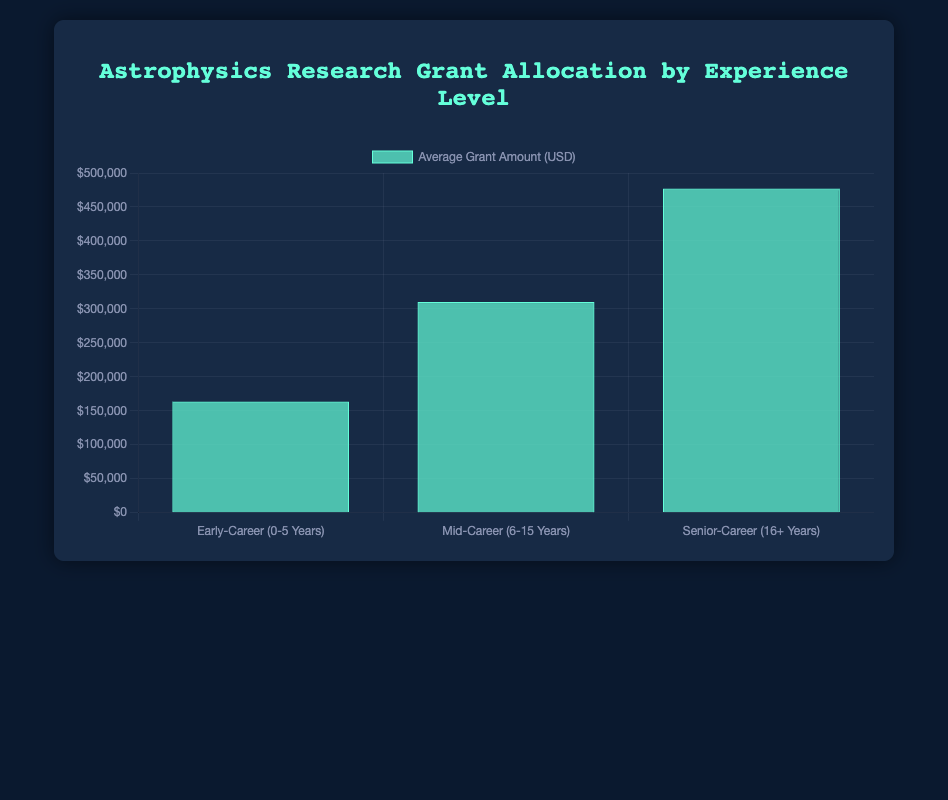What is the average grant amount for Early-Career investigators? To find the average grant amount for Early-Career investigators, sum the grant amounts for Dr. Naomi Williams, Dr. Emily Chen, and Dr. David Lee: 150,000 + 180,000 + 160,000 = 490,000. Then divide by the number of Early-Career investigators, which is 3: 490,000 / 3 = 163,333.33
Answer: 163,333.33 Which experience level received the highest average grant allocation? By looking at the bar chart, observe the height of the bars representing each experience level. The tallest bar corresponds to the Senior-Career level, indicating they received the highest average grant allocation.
Answer: Senior-Career How much more, on average, does a Senior-Career investigator receive compared to an Early-Career investigator? First, identify the average grant for Senior-Career investigators, which is depicted as approximately $476,667. The average for Early-Career is $163,333.33. Subtract the Early-Career average from the Senior-Career average: 476,667 - 163,333.33 = 313,333.67
Answer: 313,333.67 What is the total grant amount awarded to Mid-Career investigators? Sum the grant amounts for Dr. Alan Reyes, Dr. Michael Garcia, and Dr. Rachel Adams: 300,000 + 320,000 + 310,000 = 930,000
Answer: 930,000 Which experience level has the smallest average grant allocation, and what is the amount? By examining the bar chart, the shortest bar represents the Early-Career level, indicating they have the smallest average grant allocation. The amount for Early-Career investigators is approximately $163,333.33
Answer: Early-Career, 163,333.33 Compare the average grant allocations between Early-Career and Mid-Career investigators. From the chart, the average for Early-Career is approximately $163,333.33, and for Mid-Career, it's around $310,000. Mid-Career investigators receive significantly higher average grants compared to Early-Career investigators.
Answer: Mid-Career > Early-Career If the total budget for grants was $2,000,000, how much of the budget remains after allocations? The total grants awarded sum to $490,000 (Early-Career) + $930,000 (Mid-Career) + $1,430,000 (Senior-Career) = $2,850,000. Given the initial budget of $2,000,000, the remaining budget would be $2,000,000 - $2,850,000 = -$850,000, indicating an over-allocation.
Answer: -$850,000 Which institution received the highest grant amount, and what is their Principal Investigator's experience level? Identify the institution with the highest single grant amount by looking at the dataset. University of Cambridge, with a grant of $500,000 to Dr. Laura Hopkins, whose experience level is Senior-Career.
Answer: University of Cambridge, Senior-Career What is the difference between the total grant amounts allocated to Early-Career and Senior-Career investigators? Sum the grant amounts for Early-Career: 150,000 + 180,000 + 160,000 = 490,000. Sum the grant amounts for Senior-Career: 500,000 + 450,000 + 480,000 = 1,430,000. Calculate the difference: 1,430,000 - 490,000 = 940,000
Answer: 940,000 